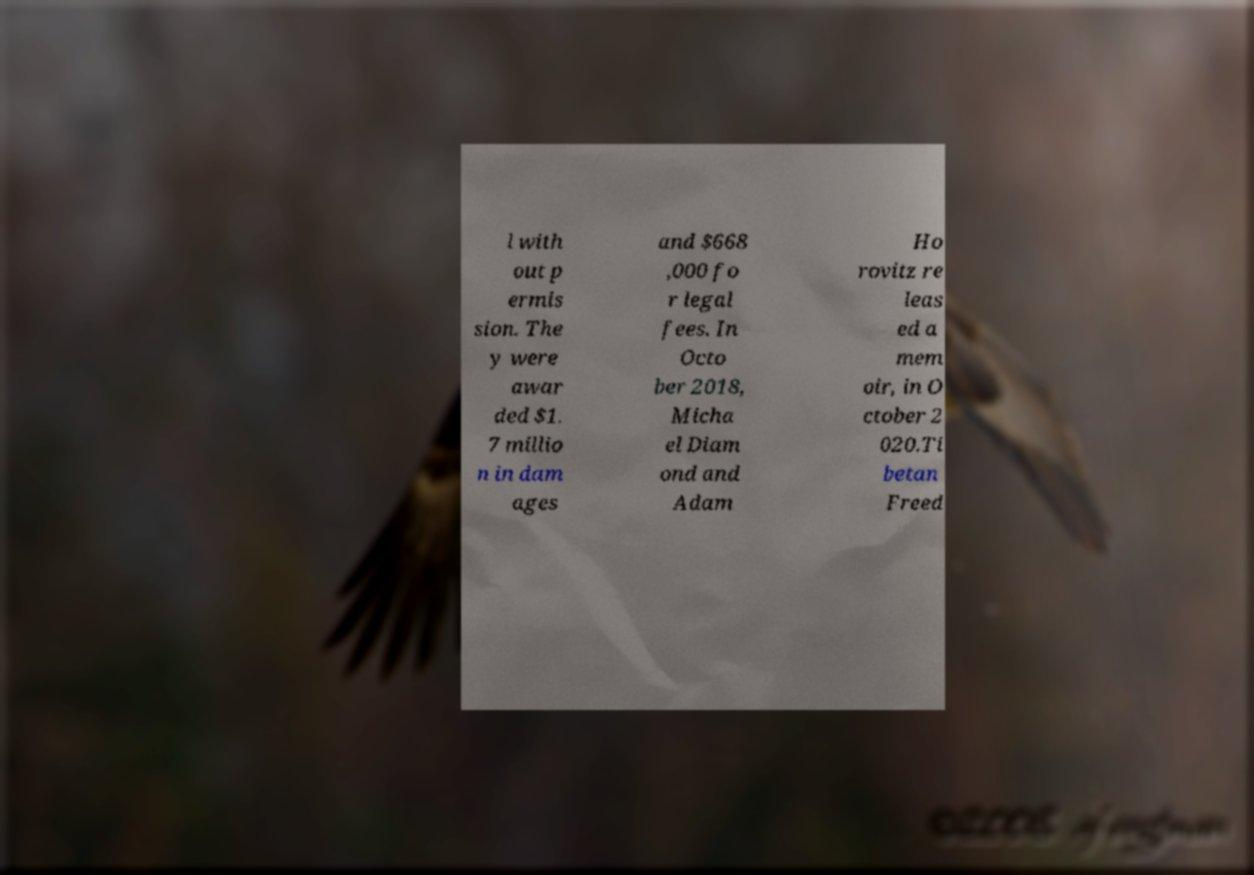Can you read and provide the text displayed in the image?This photo seems to have some interesting text. Can you extract and type it out for me? l with out p ermis sion. The y were awar ded $1. 7 millio n in dam ages and $668 ,000 fo r legal fees. In Octo ber 2018, Micha el Diam ond and Adam Ho rovitz re leas ed a mem oir, in O ctober 2 020.Ti betan Freed 